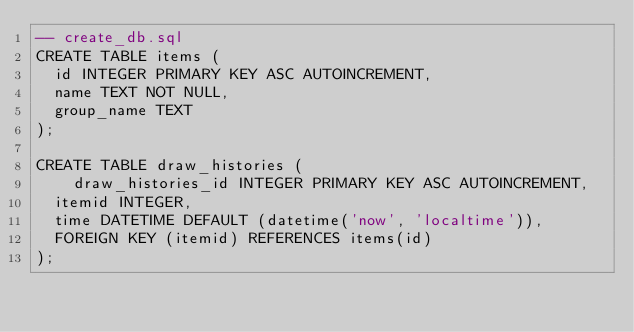Convert code to text. <code><loc_0><loc_0><loc_500><loc_500><_SQL_>-- create_db.sql
CREATE TABLE items (
	id INTEGER PRIMARY KEY ASC AUTOINCREMENT,
	name TEXT NOT NULL,
	group_name TEXT
);

CREATE TABLE draw_histories (
    draw_histories_id INTEGER PRIMARY KEY ASC AUTOINCREMENT,
	itemid INTEGER,
	time DATETIME DEFAULT (datetime('now', 'localtime')),
	FOREIGN KEY (itemid) REFERENCES items(id)
);</code> 